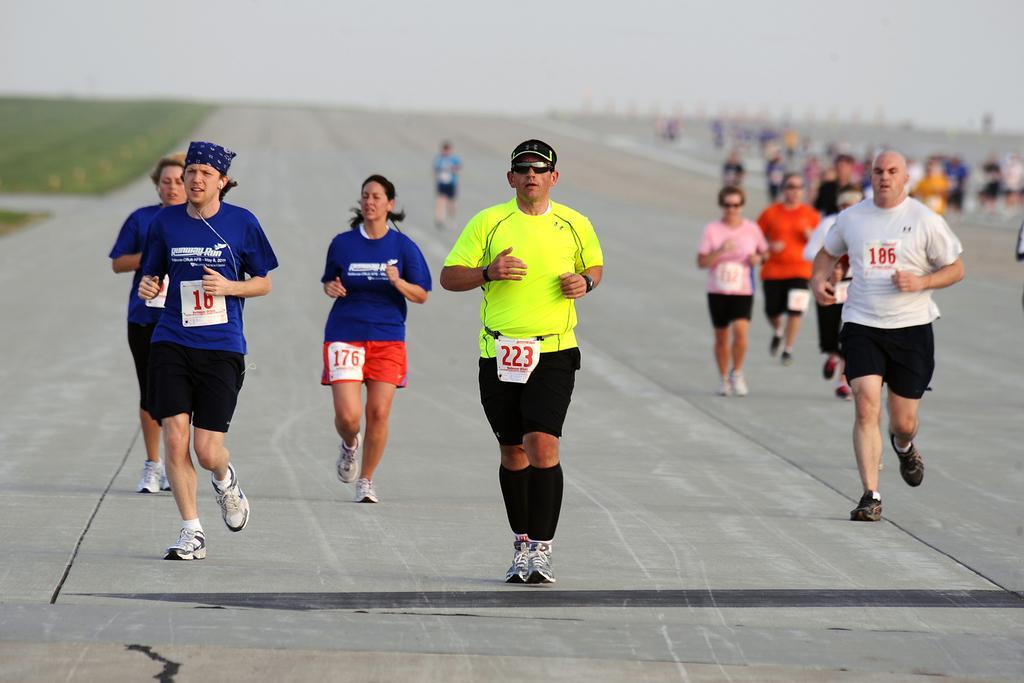Describe this image in one or two sentences. In the picture we can see a road with some people are jogging on it and in the background we can see the sky. 